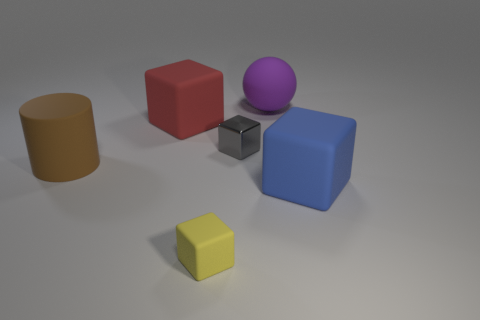Subtract 2 blocks. How many blocks are left? 2 Subtract all brown cubes. Subtract all cyan cylinders. How many cubes are left? 4 Add 1 large brown matte cylinders. How many objects exist? 7 Subtract all spheres. How many objects are left? 5 Subtract 1 brown cylinders. How many objects are left? 5 Subtract all red cubes. Subtract all large red rubber things. How many objects are left? 4 Add 1 purple matte things. How many purple matte things are left? 2 Add 2 large red matte objects. How many large red matte objects exist? 3 